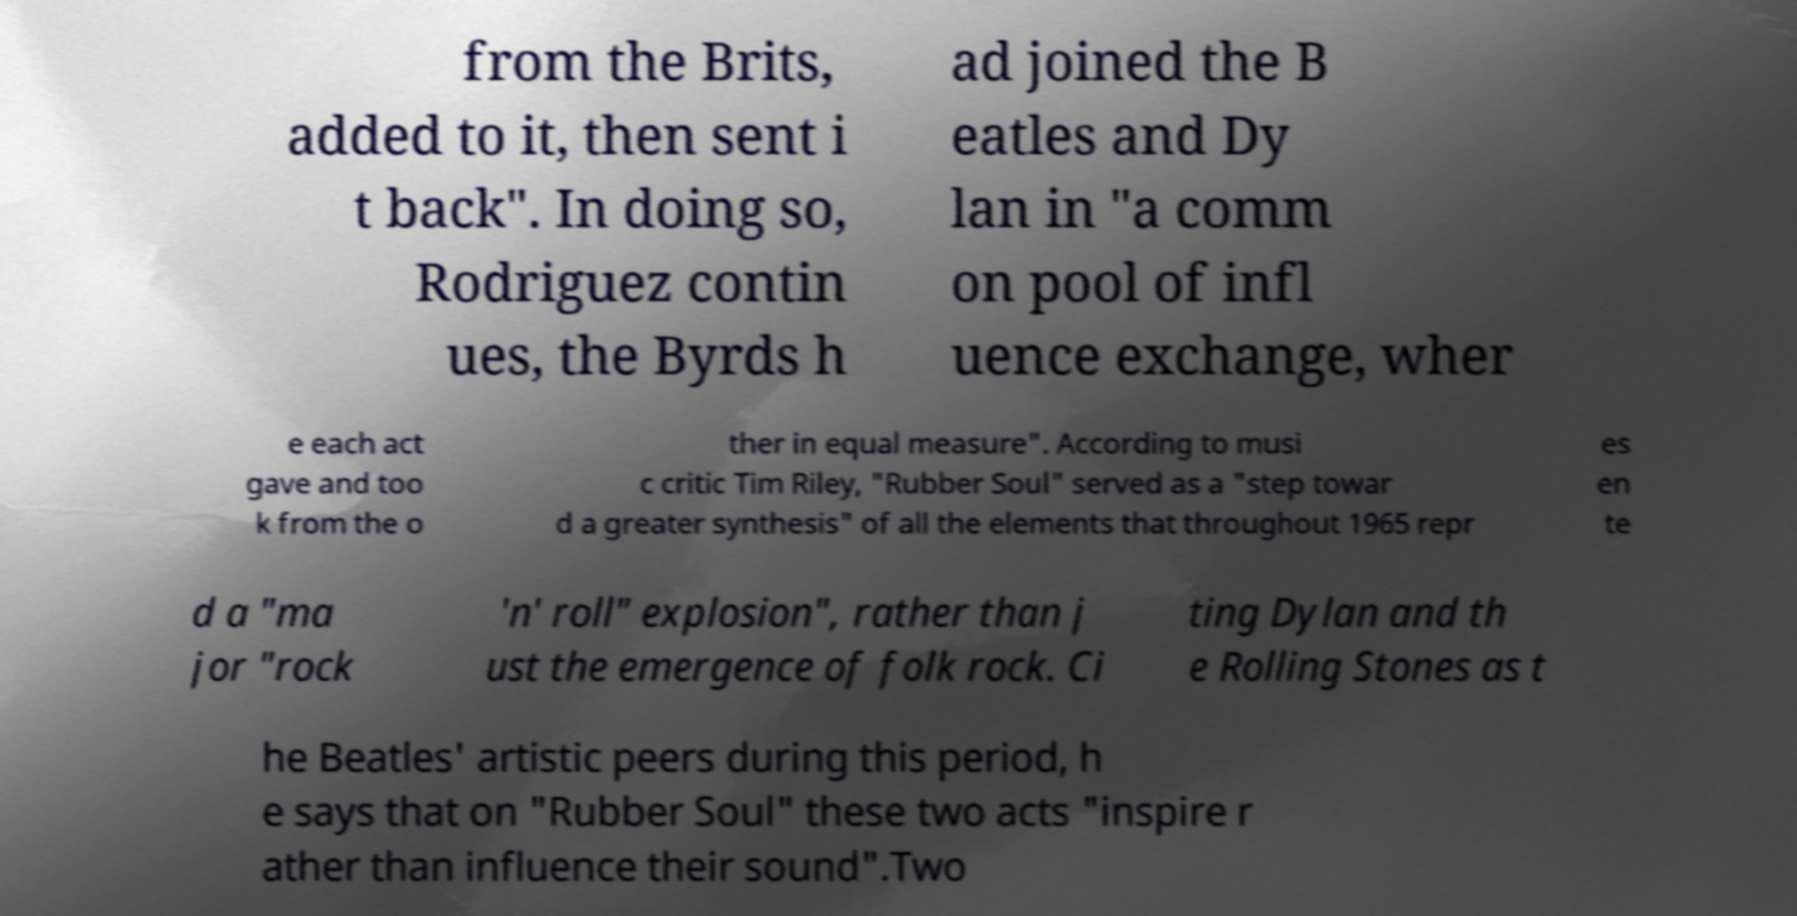For documentation purposes, I need the text within this image transcribed. Could you provide that? from the Brits, added to it, then sent i t back". In doing so, Rodriguez contin ues, the Byrds h ad joined the B eatles and Dy lan in "a comm on pool of infl uence exchange, wher e each act gave and too k from the o ther in equal measure". According to musi c critic Tim Riley, "Rubber Soul" served as a "step towar d a greater synthesis" of all the elements that throughout 1965 repr es en te d a "ma jor "rock 'n' roll" explosion", rather than j ust the emergence of folk rock. Ci ting Dylan and th e Rolling Stones as t he Beatles' artistic peers during this period, h e says that on "Rubber Soul" these two acts "inspire r ather than influence their sound".Two 